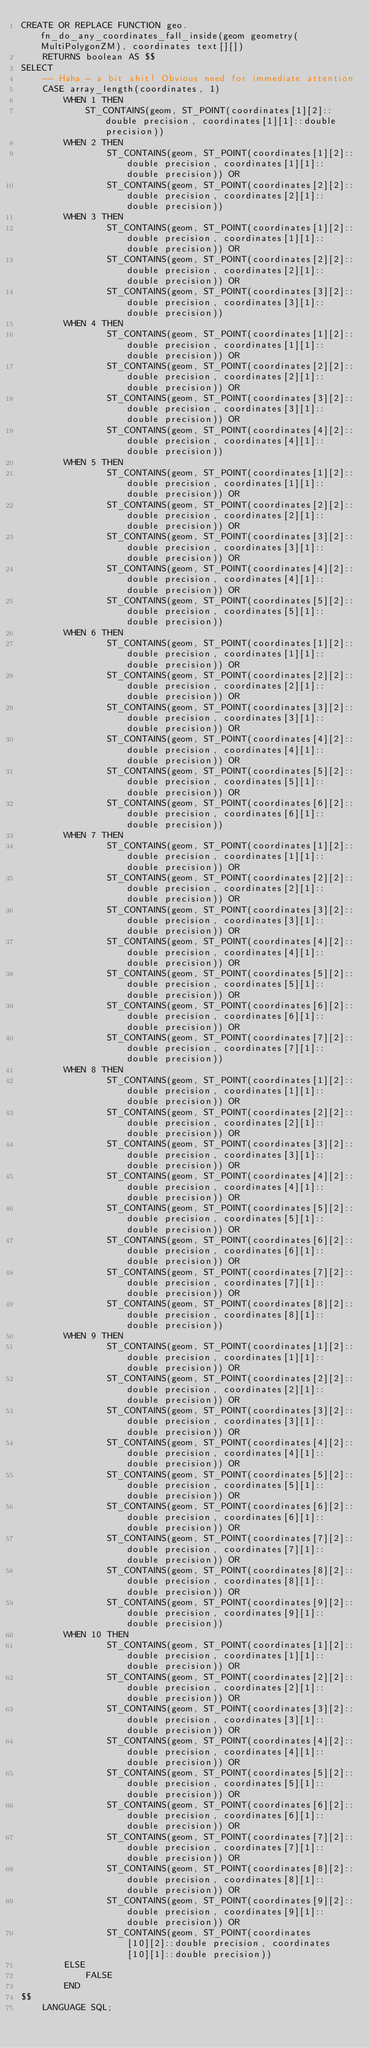<code> <loc_0><loc_0><loc_500><loc_500><_SQL_>CREATE OR REPLACE FUNCTION geo.fn_do_any_coordinates_fall_inside(geom geometry(MultiPolygonZM), coordinates text[][])
    RETURNS boolean AS $$
SELECT
    -- Haha - a bit shit! Obvious need for immediate attention
    CASE array_length(coordinates, 1)
        WHEN 1 THEN
            ST_CONTAINS(geom, ST_POINT(coordinates[1][2]::double precision, coordinates[1][1]::double precision))
        WHEN 2 THEN
                ST_CONTAINS(geom, ST_POINT(coordinates[1][2]::double precision, coordinates[1][1]::double precision)) OR
                ST_CONTAINS(geom, ST_POINT(coordinates[2][2]::double precision, coordinates[2][1]::double precision))
        WHEN 3 THEN
                ST_CONTAINS(geom, ST_POINT(coordinates[1][2]::double precision, coordinates[1][1]::double precision)) OR
                ST_CONTAINS(geom, ST_POINT(coordinates[2][2]::double precision, coordinates[2][1]::double precision)) OR
                ST_CONTAINS(geom, ST_POINT(coordinates[3][2]::double precision, coordinates[3][1]::double precision))
        WHEN 4 THEN
                ST_CONTAINS(geom, ST_POINT(coordinates[1][2]::double precision, coordinates[1][1]::double precision)) OR
                ST_CONTAINS(geom, ST_POINT(coordinates[2][2]::double precision, coordinates[2][1]::double precision)) OR
                ST_CONTAINS(geom, ST_POINT(coordinates[3][2]::double precision, coordinates[3][1]::double precision)) OR
                ST_CONTAINS(geom, ST_POINT(coordinates[4][2]::double precision, coordinates[4][1]::double precision))
        WHEN 5 THEN
                ST_CONTAINS(geom, ST_POINT(coordinates[1][2]::double precision, coordinates[1][1]::double precision)) OR
                ST_CONTAINS(geom, ST_POINT(coordinates[2][2]::double precision, coordinates[2][1]::double precision)) OR
                ST_CONTAINS(geom, ST_POINT(coordinates[3][2]::double precision, coordinates[3][1]::double precision)) OR
                ST_CONTAINS(geom, ST_POINT(coordinates[4][2]::double precision, coordinates[4][1]::double precision)) OR
                ST_CONTAINS(geom, ST_POINT(coordinates[5][2]::double precision, coordinates[5][1]::double precision))
        WHEN 6 THEN
                ST_CONTAINS(geom, ST_POINT(coordinates[1][2]::double precision, coordinates[1][1]::double precision)) OR
                ST_CONTAINS(geom, ST_POINT(coordinates[2][2]::double precision, coordinates[2][1]::double precision)) OR
                ST_CONTAINS(geom, ST_POINT(coordinates[3][2]::double precision, coordinates[3][1]::double precision)) OR
                ST_CONTAINS(geom, ST_POINT(coordinates[4][2]::double precision, coordinates[4][1]::double precision)) OR
                ST_CONTAINS(geom, ST_POINT(coordinates[5][2]::double precision, coordinates[5][1]::double precision)) OR
                ST_CONTAINS(geom, ST_POINT(coordinates[6][2]::double precision, coordinates[6][1]::double precision))
        WHEN 7 THEN
                ST_CONTAINS(geom, ST_POINT(coordinates[1][2]::double precision, coordinates[1][1]::double precision)) OR
                ST_CONTAINS(geom, ST_POINT(coordinates[2][2]::double precision, coordinates[2][1]::double precision)) OR
                ST_CONTAINS(geom, ST_POINT(coordinates[3][2]::double precision, coordinates[3][1]::double precision)) OR
                ST_CONTAINS(geom, ST_POINT(coordinates[4][2]::double precision, coordinates[4][1]::double precision)) OR
                ST_CONTAINS(geom, ST_POINT(coordinates[5][2]::double precision, coordinates[5][1]::double precision)) OR
                ST_CONTAINS(geom, ST_POINT(coordinates[6][2]::double precision, coordinates[6][1]::double precision)) OR
                ST_CONTAINS(geom, ST_POINT(coordinates[7][2]::double precision, coordinates[7][1]::double precision))
        WHEN 8 THEN
                ST_CONTAINS(geom, ST_POINT(coordinates[1][2]::double precision, coordinates[1][1]::double precision)) OR
                ST_CONTAINS(geom, ST_POINT(coordinates[2][2]::double precision, coordinates[2][1]::double precision)) OR
                ST_CONTAINS(geom, ST_POINT(coordinates[3][2]::double precision, coordinates[3][1]::double precision)) OR
                ST_CONTAINS(geom, ST_POINT(coordinates[4][2]::double precision, coordinates[4][1]::double precision)) OR
                ST_CONTAINS(geom, ST_POINT(coordinates[5][2]::double precision, coordinates[5][1]::double precision)) OR
                ST_CONTAINS(geom, ST_POINT(coordinates[6][2]::double precision, coordinates[6][1]::double precision)) OR
                ST_CONTAINS(geom, ST_POINT(coordinates[7][2]::double precision, coordinates[7][1]::double precision)) OR
                ST_CONTAINS(geom, ST_POINT(coordinates[8][2]::double precision, coordinates[8][1]::double precision))
        WHEN 9 THEN
                ST_CONTAINS(geom, ST_POINT(coordinates[1][2]::double precision, coordinates[1][1]::double precision)) OR
                ST_CONTAINS(geom, ST_POINT(coordinates[2][2]::double precision, coordinates[2][1]::double precision)) OR
                ST_CONTAINS(geom, ST_POINT(coordinates[3][2]::double precision, coordinates[3][1]::double precision)) OR
                ST_CONTAINS(geom, ST_POINT(coordinates[4][2]::double precision, coordinates[4][1]::double precision)) OR
                ST_CONTAINS(geom, ST_POINT(coordinates[5][2]::double precision, coordinates[5][1]::double precision)) OR
                ST_CONTAINS(geom, ST_POINT(coordinates[6][2]::double precision, coordinates[6][1]::double precision)) OR
                ST_CONTAINS(geom, ST_POINT(coordinates[7][2]::double precision, coordinates[7][1]::double precision)) OR
                ST_CONTAINS(geom, ST_POINT(coordinates[8][2]::double precision, coordinates[8][1]::double precision)) OR
                ST_CONTAINS(geom, ST_POINT(coordinates[9][2]::double precision, coordinates[9][1]::double precision))
        WHEN 10 THEN
                ST_CONTAINS(geom, ST_POINT(coordinates[1][2]::double precision, coordinates[1][1]::double precision)) OR
                ST_CONTAINS(geom, ST_POINT(coordinates[2][2]::double precision, coordinates[2][1]::double precision)) OR
                ST_CONTAINS(geom, ST_POINT(coordinates[3][2]::double precision, coordinates[3][1]::double precision)) OR
                ST_CONTAINS(geom, ST_POINT(coordinates[4][2]::double precision, coordinates[4][1]::double precision)) OR
                ST_CONTAINS(geom, ST_POINT(coordinates[5][2]::double precision, coordinates[5][1]::double precision)) OR
                ST_CONTAINS(geom, ST_POINT(coordinates[6][2]::double precision, coordinates[6][1]::double precision)) OR
                ST_CONTAINS(geom, ST_POINT(coordinates[7][2]::double precision, coordinates[7][1]::double precision)) OR
                ST_CONTAINS(geom, ST_POINT(coordinates[8][2]::double precision, coordinates[8][1]::double precision)) OR
                ST_CONTAINS(geom, ST_POINT(coordinates[9][2]::double precision, coordinates[9][1]::double precision)) OR
                ST_CONTAINS(geom, ST_POINT(coordinates[10][2]::double precision, coordinates[10][1]::double precision))
        ELSE
            FALSE
        END
$$
    LANGUAGE SQL;</code> 